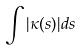<formula> <loc_0><loc_0><loc_500><loc_500>\int | \kappa ( s ) | d s</formula> 